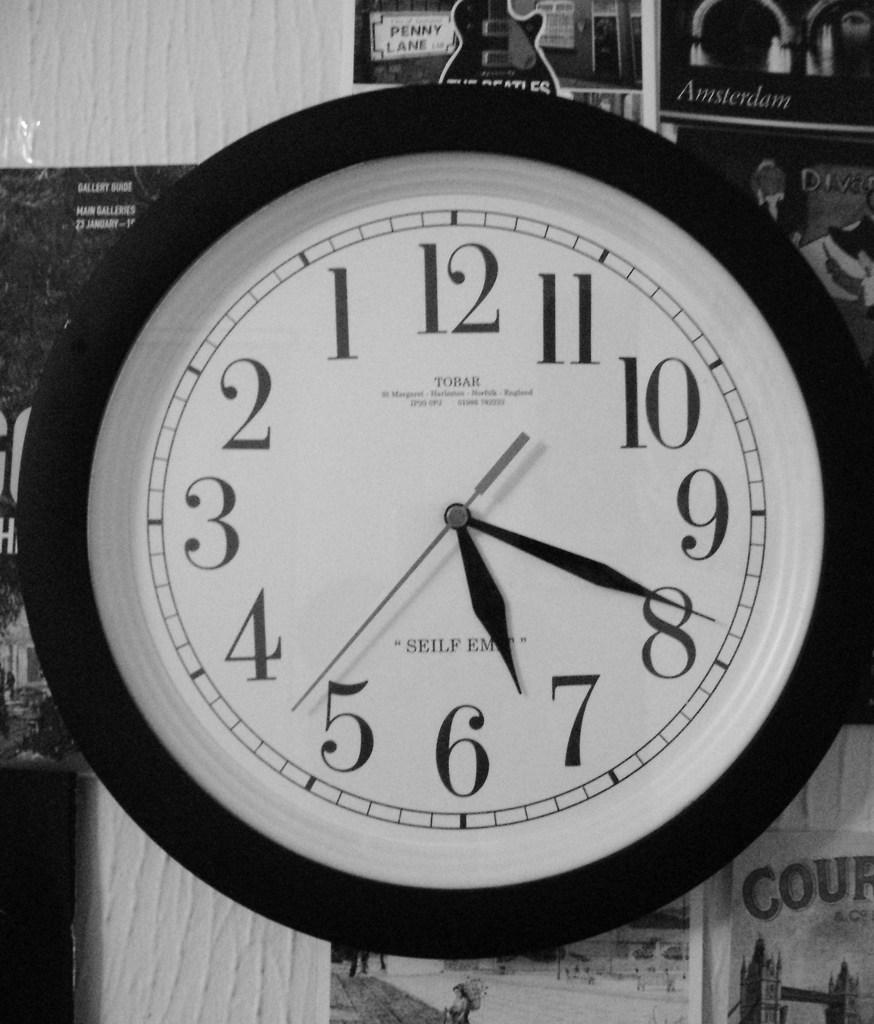What time does the clock say?
Give a very brief answer. 6:41. What is a word found on the clock?
Your response must be concise. Tobar. 